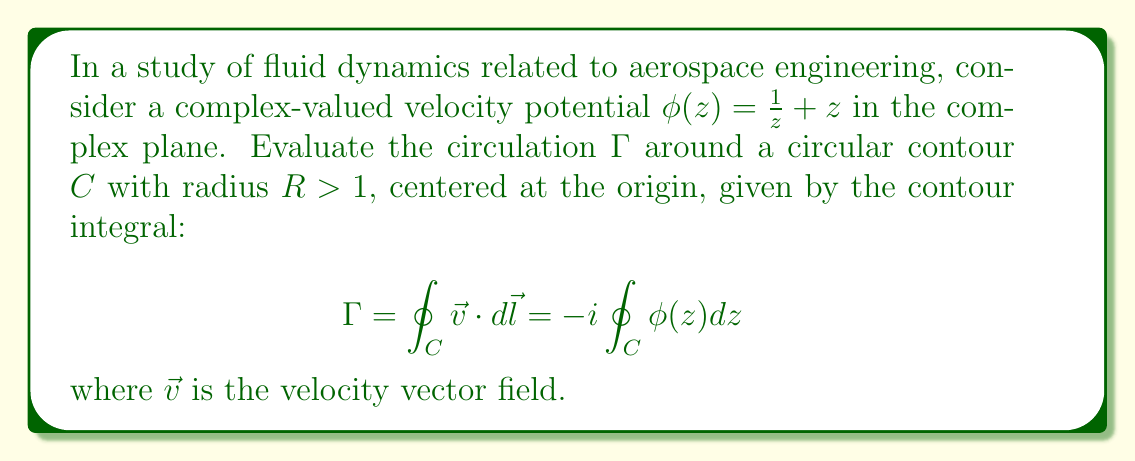Could you help me with this problem? 1) First, we need to parametrize the contour $C$. Let $z = Re^{i\theta}$, where $\theta$ goes from 0 to $2\pi$.

2) The differential $dz$ can be written as $iRe^{i\theta}d\theta$.

3) Substituting these into the integral:

   $$\Gamma = -i \oint_C \phi(z) dz = -i \int_0^{2\pi} \left(\frac{1}{Re^{i\theta}} + Re^{i\theta}\right) \cdot iRe^{i\theta}d\theta$$

4) Simplify:

   $$\Gamma = -i \int_0^{2\pi} \left(i + iR^2e^{2i\theta}\right) d\theta = \int_0^{2\pi} \left(1 + R^2e^{2i\theta}\right) d\theta$$

5) Split the integral:

   $$\Gamma = \int_0^{2\pi} 1 d\theta + R^2 \int_0^{2\pi} e^{2i\theta} d\theta$$

6) The first integral is straightforward:

   $$\int_0^{2\pi} 1 d\theta = 2\pi$$

7) For the second integral, note that $\int_0^{2\pi} e^{in\theta} d\theta = 0$ for any non-zero integer $n$. Here, $n=2$.

8) Therefore, the second integral evaluates to zero.

9) The final result is:

   $$\Gamma = 2\pi + 0 = 2\pi$$
Answer: $2\pi$ 